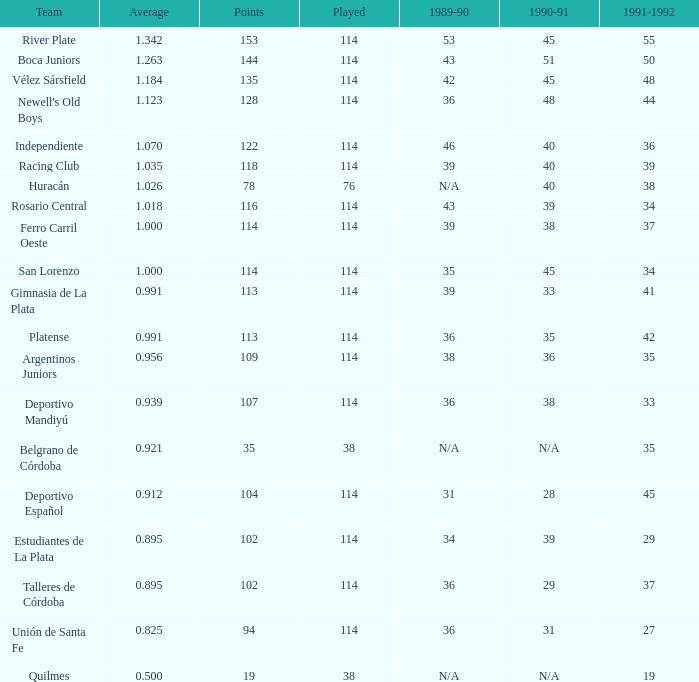What is the amount for 1991-1992 if the 1989-90 value is 36 and the average is 0.8250000000000001? 0.0. 